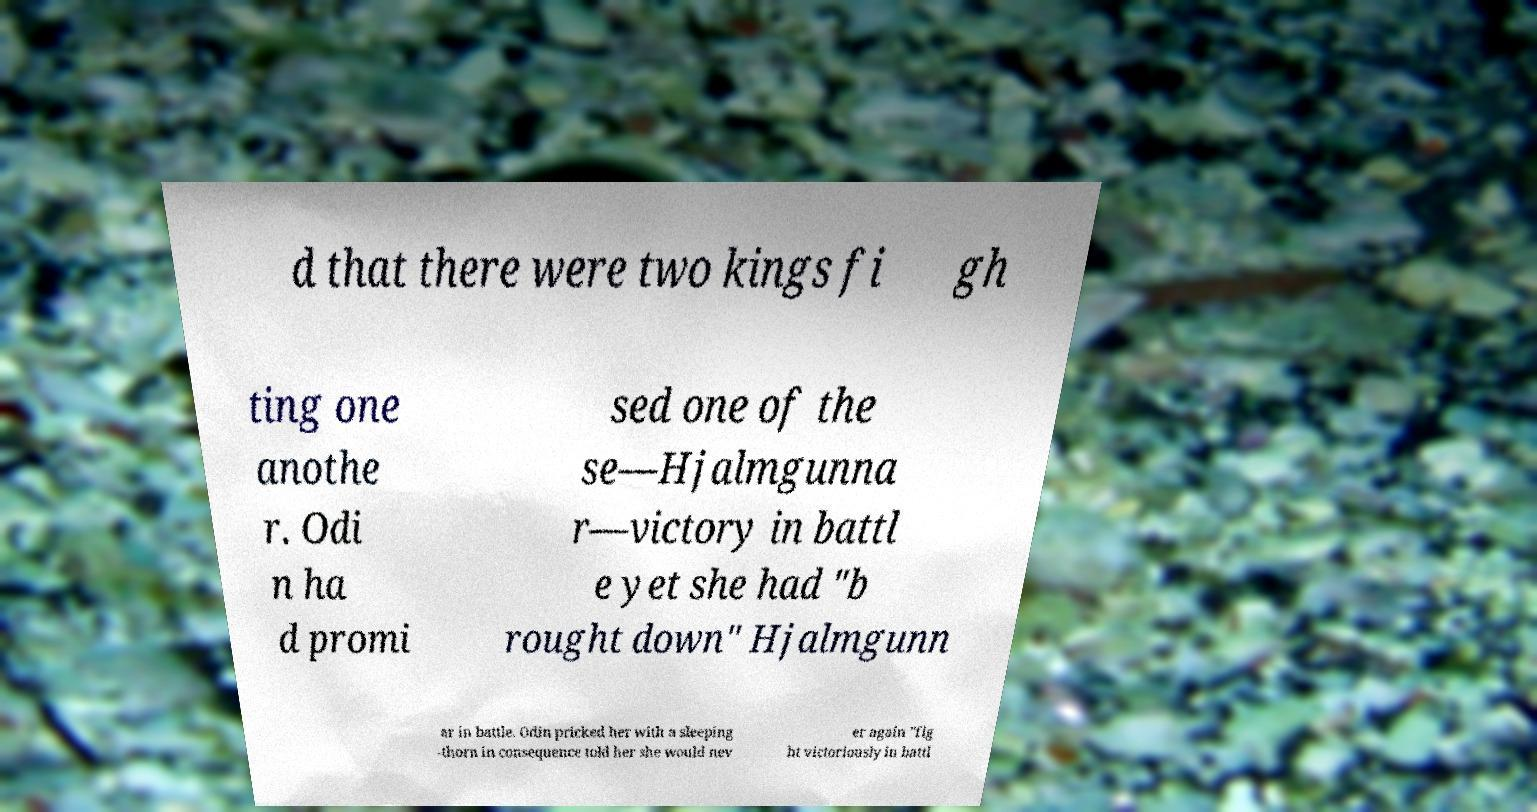There's text embedded in this image that I need extracted. Can you transcribe it verbatim? d that there were two kings fi gh ting one anothe r. Odi n ha d promi sed one of the se—Hjalmgunna r—victory in battl e yet she had "b rought down" Hjalmgunn ar in battle. Odin pricked her with a sleeping -thorn in consequence told her she would nev er again "fig ht victoriously in battl 